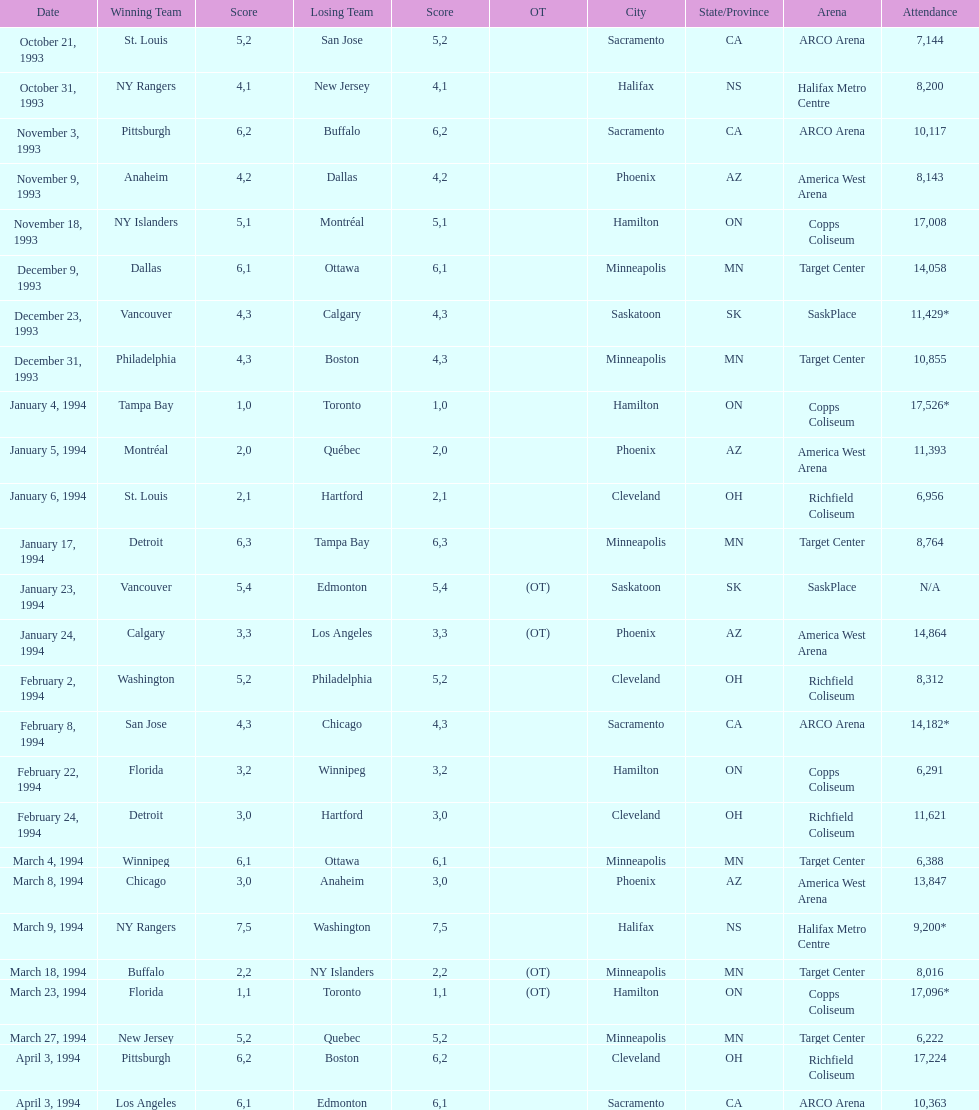How many neutral site games resulted in overtime (ot)? 4. 